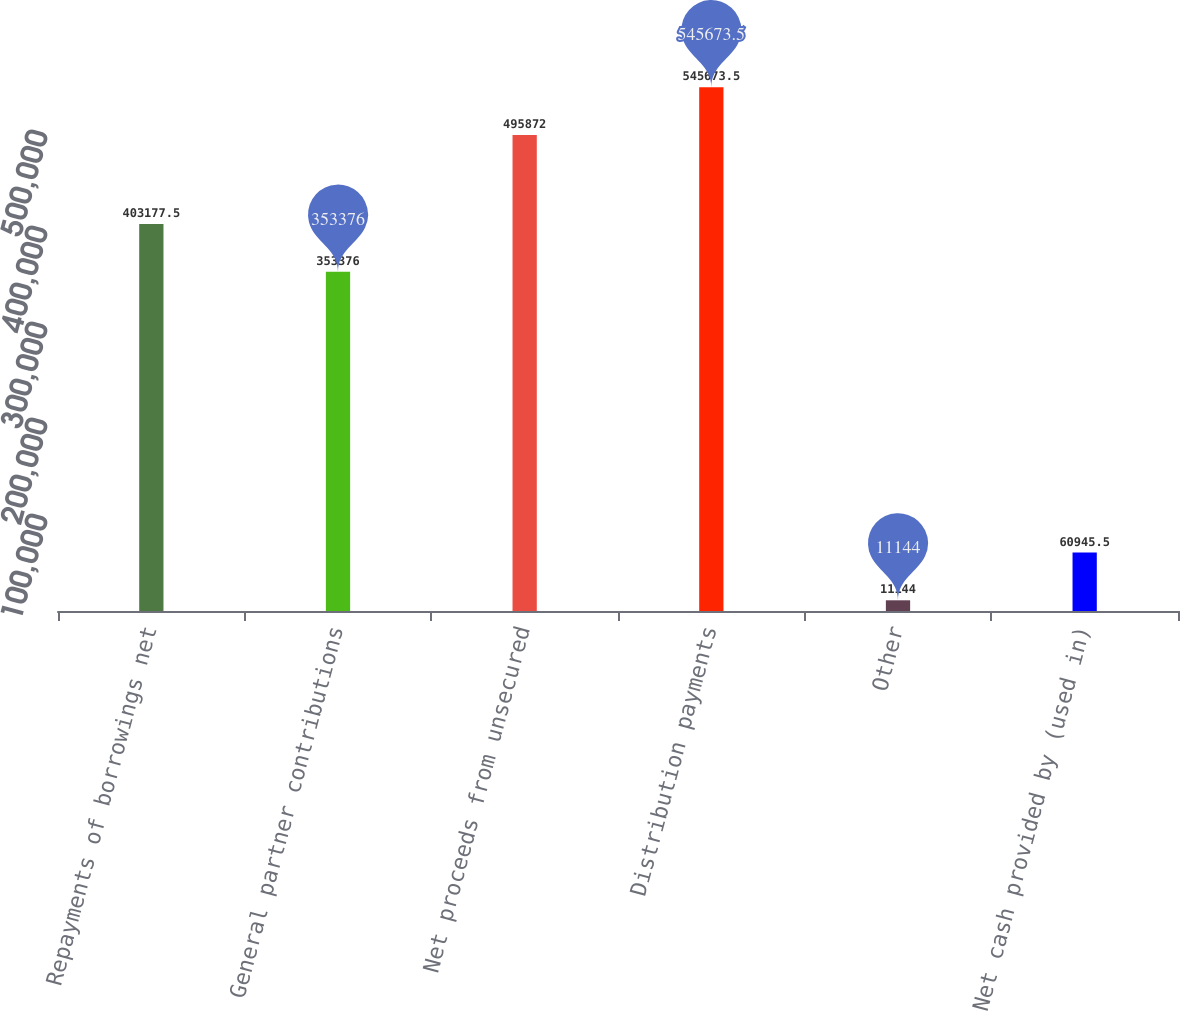Convert chart. <chart><loc_0><loc_0><loc_500><loc_500><bar_chart><fcel>Repayments of borrowings net<fcel>General partner contributions<fcel>Net proceeds from unsecured<fcel>Distribution payments<fcel>Other<fcel>Net cash provided by (used in)<nl><fcel>403178<fcel>353376<fcel>495872<fcel>545674<fcel>11144<fcel>60945.5<nl></chart> 